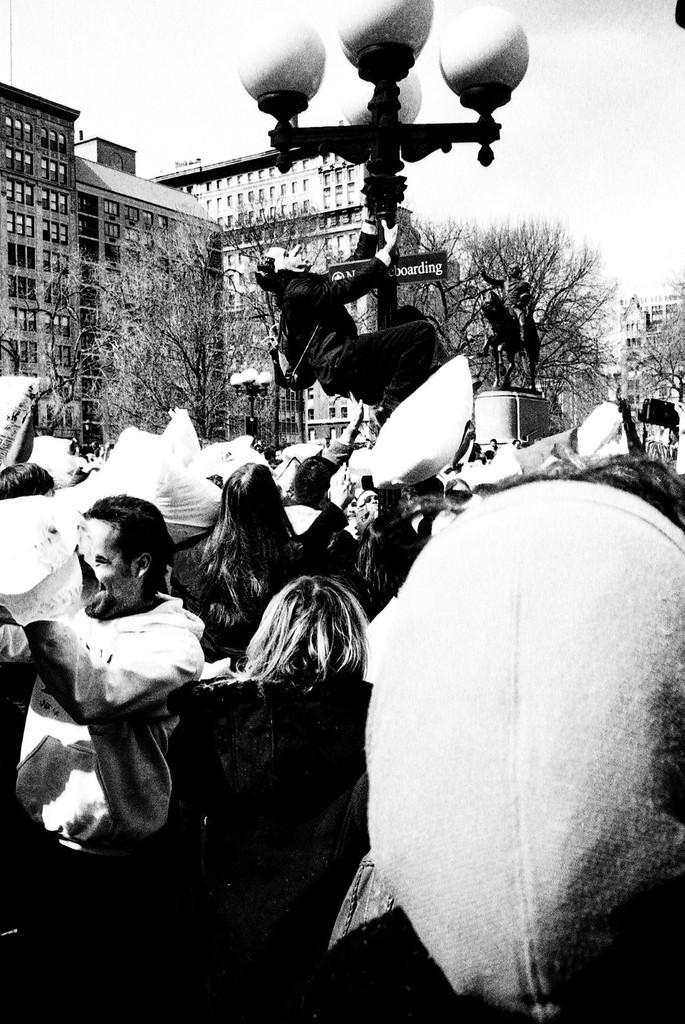How would you summarize this image in a sentence or two? This is a black and white image. In this image we can see persons, light, trees, buildings and sky. 